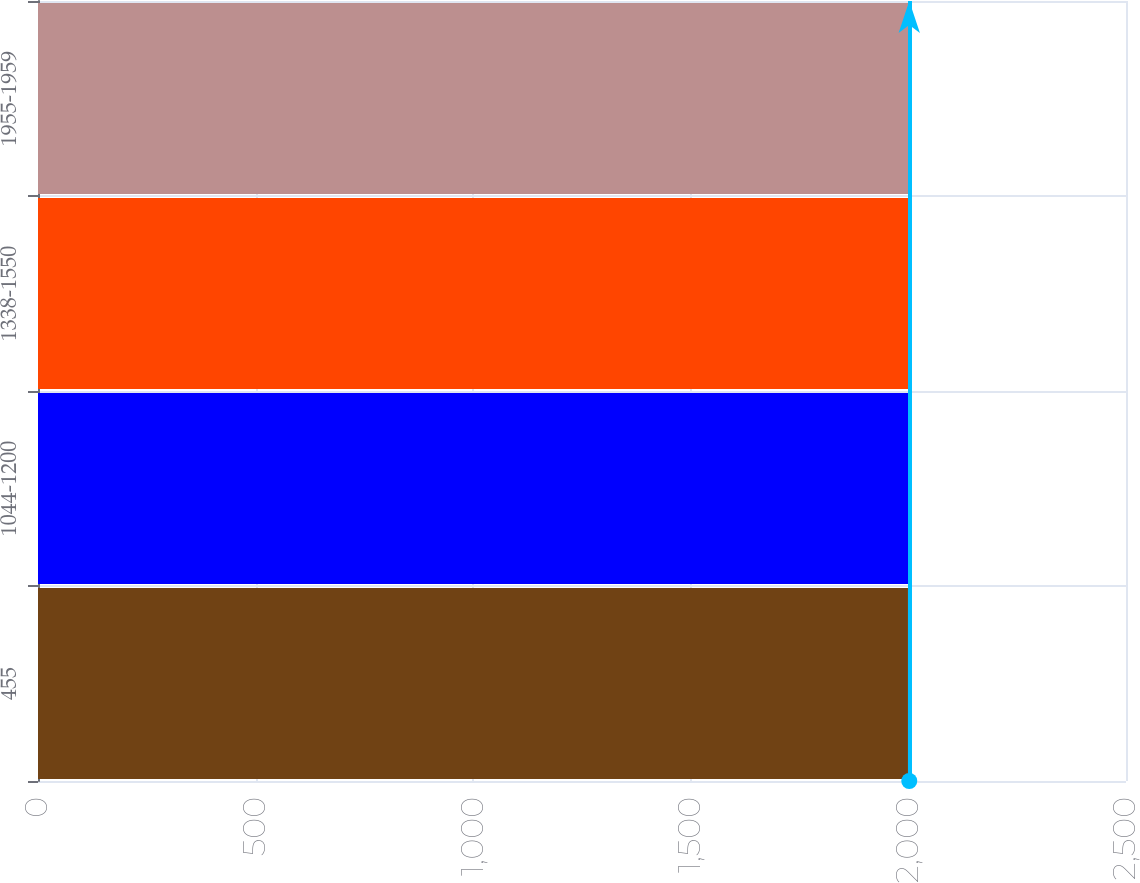Convert chart to OTSL. <chart><loc_0><loc_0><loc_500><loc_500><bar_chart><fcel>455<fcel>1044-1200<fcel>1338-1550<fcel>1955-1959<nl><fcel>1999<fcel>2000<fcel>2001<fcel>2002<nl></chart> 